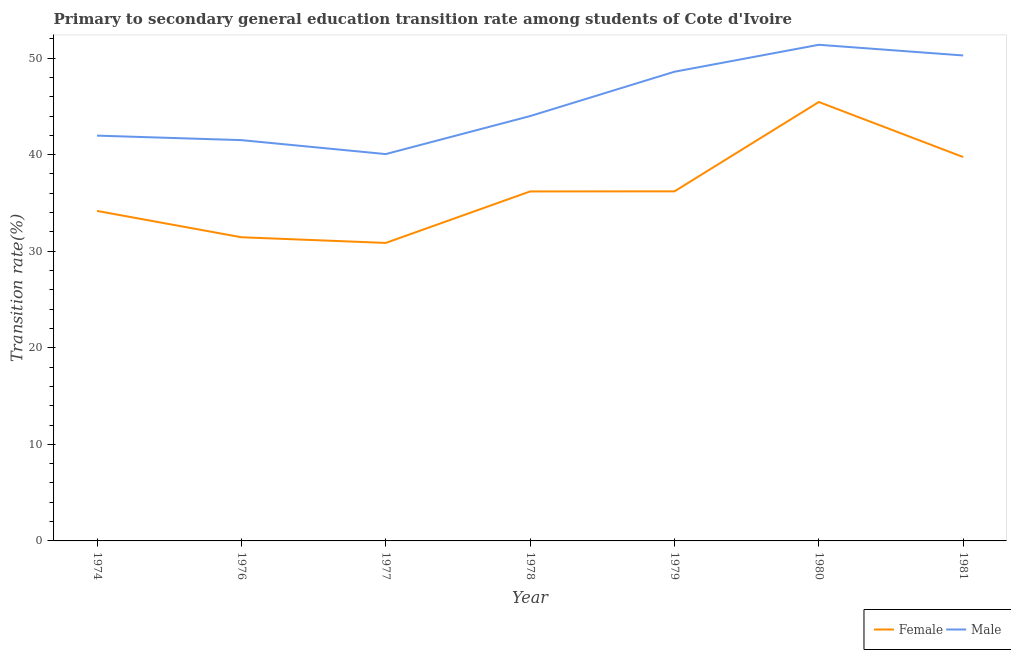How many different coloured lines are there?
Your answer should be very brief. 2. What is the transition rate among female students in 1979?
Ensure brevity in your answer.  36.2. Across all years, what is the maximum transition rate among female students?
Provide a short and direct response. 45.46. Across all years, what is the minimum transition rate among male students?
Offer a terse response. 40.06. In which year was the transition rate among male students maximum?
Your answer should be compact. 1980. What is the total transition rate among female students in the graph?
Offer a terse response. 254.09. What is the difference between the transition rate among male students in 1977 and that in 1978?
Your answer should be compact. -3.94. What is the difference between the transition rate among female students in 1980 and the transition rate among male students in 1978?
Your answer should be very brief. 1.46. What is the average transition rate among female students per year?
Give a very brief answer. 36.3. In the year 1974, what is the difference between the transition rate among female students and transition rate among male students?
Offer a very short reply. -7.8. In how many years, is the transition rate among female students greater than 32 %?
Offer a very short reply. 5. What is the ratio of the transition rate among male students in 1976 to that in 1977?
Make the answer very short. 1.04. Is the transition rate among male students in 1974 less than that in 1981?
Ensure brevity in your answer.  Yes. Is the difference between the transition rate among female students in 1980 and 1981 greater than the difference between the transition rate among male students in 1980 and 1981?
Provide a succinct answer. Yes. What is the difference between the highest and the second highest transition rate among male students?
Keep it short and to the point. 1.11. What is the difference between the highest and the lowest transition rate among male students?
Keep it short and to the point. 11.32. Is the transition rate among male students strictly greater than the transition rate among female students over the years?
Your response must be concise. Yes. Are the values on the major ticks of Y-axis written in scientific E-notation?
Make the answer very short. No. Does the graph contain any zero values?
Make the answer very short. No. Where does the legend appear in the graph?
Ensure brevity in your answer.  Bottom right. What is the title of the graph?
Your answer should be compact. Primary to secondary general education transition rate among students of Cote d'Ivoire. Does "Largest city" appear as one of the legend labels in the graph?
Keep it short and to the point. No. What is the label or title of the Y-axis?
Ensure brevity in your answer.  Transition rate(%). What is the Transition rate(%) in Female in 1974?
Your response must be concise. 34.18. What is the Transition rate(%) of Male in 1974?
Give a very brief answer. 41.97. What is the Transition rate(%) of Female in 1976?
Give a very brief answer. 31.45. What is the Transition rate(%) in Male in 1976?
Your response must be concise. 41.51. What is the Transition rate(%) of Female in 1977?
Keep it short and to the point. 30.86. What is the Transition rate(%) in Male in 1977?
Make the answer very short. 40.06. What is the Transition rate(%) in Female in 1978?
Give a very brief answer. 36.19. What is the Transition rate(%) in Male in 1978?
Your answer should be compact. 44. What is the Transition rate(%) in Female in 1979?
Ensure brevity in your answer.  36.2. What is the Transition rate(%) of Male in 1979?
Your answer should be very brief. 48.59. What is the Transition rate(%) in Female in 1980?
Keep it short and to the point. 45.46. What is the Transition rate(%) in Male in 1980?
Provide a succinct answer. 51.38. What is the Transition rate(%) of Female in 1981?
Offer a very short reply. 39.75. What is the Transition rate(%) in Male in 1981?
Provide a short and direct response. 50.28. Across all years, what is the maximum Transition rate(%) in Female?
Provide a short and direct response. 45.46. Across all years, what is the maximum Transition rate(%) of Male?
Offer a very short reply. 51.38. Across all years, what is the minimum Transition rate(%) of Female?
Provide a short and direct response. 30.86. Across all years, what is the minimum Transition rate(%) in Male?
Offer a terse response. 40.06. What is the total Transition rate(%) of Female in the graph?
Offer a very short reply. 254.09. What is the total Transition rate(%) in Male in the graph?
Offer a terse response. 317.79. What is the difference between the Transition rate(%) of Female in 1974 and that in 1976?
Offer a very short reply. 2.73. What is the difference between the Transition rate(%) of Male in 1974 and that in 1976?
Ensure brevity in your answer.  0.47. What is the difference between the Transition rate(%) of Female in 1974 and that in 1977?
Provide a short and direct response. 3.32. What is the difference between the Transition rate(%) in Male in 1974 and that in 1977?
Your answer should be very brief. 1.91. What is the difference between the Transition rate(%) in Female in 1974 and that in 1978?
Your answer should be very brief. -2.02. What is the difference between the Transition rate(%) of Male in 1974 and that in 1978?
Ensure brevity in your answer.  -2.02. What is the difference between the Transition rate(%) in Female in 1974 and that in 1979?
Your answer should be compact. -2.03. What is the difference between the Transition rate(%) of Male in 1974 and that in 1979?
Your response must be concise. -6.62. What is the difference between the Transition rate(%) of Female in 1974 and that in 1980?
Make the answer very short. -11.28. What is the difference between the Transition rate(%) of Male in 1974 and that in 1980?
Make the answer very short. -9.41. What is the difference between the Transition rate(%) of Female in 1974 and that in 1981?
Your response must be concise. -5.58. What is the difference between the Transition rate(%) in Male in 1974 and that in 1981?
Your answer should be very brief. -8.3. What is the difference between the Transition rate(%) in Female in 1976 and that in 1977?
Your answer should be compact. 0.59. What is the difference between the Transition rate(%) of Male in 1976 and that in 1977?
Offer a terse response. 1.45. What is the difference between the Transition rate(%) of Female in 1976 and that in 1978?
Your answer should be compact. -4.74. What is the difference between the Transition rate(%) in Male in 1976 and that in 1978?
Offer a terse response. -2.49. What is the difference between the Transition rate(%) in Female in 1976 and that in 1979?
Ensure brevity in your answer.  -4.75. What is the difference between the Transition rate(%) of Male in 1976 and that in 1979?
Your answer should be compact. -7.08. What is the difference between the Transition rate(%) in Female in 1976 and that in 1980?
Provide a succinct answer. -14.01. What is the difference between the Transition rate(%) in Male in 1976 and that in 1980?
Ensure brevity in your answer.  -9.87. What is the difference between the Transition rate(%) in Female in 1976 and that in 1981?
Keep it short and to the point. -8.31. What is the difference between the Transition rate(%) of Male in 1976 and that in 1981?
Offer a very short reply. -8.77. What is the difference between the Transition rate(%) of Female in 1977 and that in 1978?
Offer a terse response. -5.33. What is the difference between the Transition rate(%) in Male in 1977 and that in 1978?
Offer a terse response. -3.94. What is the difference between the Transition rate(%) in Female in 1977 and that in 1979?
Your response must be concise. -5.34. What is the difference between the Transition rate(%) in Male in 1977 and that in 1979?
Offer a terse response. -8.53. What is the difference between the Transition rate(%) in Female in 1977 and that in 1980?
Provide a short and direct response. -14.59. What is the difference between the Transition rate(%) of Male in 1977 and that in 1980?
Offer a very short reply. -11.32. What is the difference between the Transition rate(%) in Female in 1977 and that in 1981?
Ensure brevity in your answer.  -8.89. What is the difference between the Transition rate(%) of Male in 1977 and that in 1981?
Provide a short and direct response. -10.21. What is the difference between the Transition rate(%) of Female in 1978 and that in 1979?
Your answer should be very brief. -0.01. What is the difference between the Transition rate(%) in Male in 1978 and that in 1979?
Offer a terse response. -4.59. What is the difference between the Transition rate(%) of Female in 1978 and that in 1980?
Make the answer very short. -9.26. What is the difference between the Transition rate(%) in Male in 1978 and that in 1980?
Provide a short and direct response. -7.38. What is the difference between the Transition rate(%) in Female in 1978 and that in 1981?
Offer a terse response. -3.56. What is the difference between the Transition rate(%) of Male in 1978 and that in 1981?
Your response must be concise. -6.28. What is the difference between the Transition rate(%) in Female in 1979 and that in 1980?
Ensure brevity in your answer.  -9.25. What is the difference between the Transition rate(%) in Male in 1979 and that in 1980?
Provide a succinct answer. -2.79. What is the difference between the Transition rate(%) of Female in 1979 and that in 1981?
Make the answer very short. -3.55. What is the difference between the Transition rate(%) in Male in 1979 and that in 1981?
Give a very brief answer. -1.69. What is the difference between the Transition rate(%) of Female in 1980 and that in 1981?
Make the answer very short. 5.7. What is the difference between the Transition rate(%) of Male in 1980 and that in 1981?
Offer a terse response. 1.11. What is the difference between the Transition rate(%) of Female in 1974 and the Transition rate(%) of Male in 1976?
Your response must be concise. -7.33. What is the difference between the Transition rate(%) in Female in 1974 and the Transition rate(%) in Male in 1977?
Provide a succinct answer. -5.89. What is the difference between the Transition rate(%) in Female in 1974 and the Transition rate(%) in Male in 1978?
Ensure brevity in your answer.  -9.82. What is the difference between the Transition rate(%) of Female in 1974 and the Transition rate(%) of Male in 1979?
Your answer should be compact. -14.41. What is the difference between the Transition rate(%) of Female in 1974 and the Transition rate(%) of Male in 1980?
Offer a terse response. -17.21. What is the difference between the Transition rate(%) in Female in 1974 and the Transition rate(%) in Male in 1981?
Keep it short and to the point. -16.1. What is the difference between the Transition rate(%) of Female in 1976 and the Transition rate(%) of Male in 1977?
Your answer should be very brief. -8.61. What is the difference between the Transition rate(%) in Female in 1976 and the Transition rate(%) in Male in 1978?
Your answer should be compact. -12.55. What is the difference between the Transition rate(%) of Female in 1976 and the Transition rate(%) of Male in 1979?
Keep it short and to the point. -17.14. What is the difference between the Transition rate(%) of Female in 1976 and the Transition rate(%) of Male in 1980?
Provide a short and direct response. -19.93. What is the difference between the Transition rate(%) of Female in 1976 and the Transition rate(%) of Male in 1981?
Keep it short and to the point. -18.83. What is the difference between the Transition rate(%) of Female in 1977 and the Transition rate(%) of Male in 1978?
Provide a succinct answer. -13.14. What is the difference between the Transition rate(%) of Female in 1977 and the Transition rate(%) of Male in 1979?
Ensure brevity in your answer.  -17.73. What is the difference between the Transition rate(%) in Female in 1977 and the Transition rate(%) in Male in 1980?
Offer a very short reply. -20.52. What is the difference between the Transition rate(%) of Female in 1977 and the Transition rate(%) of Male in 1981?
Offer a very short reply. -19.41. What is the difference between the Transition rate(%) of Female in 1978 and the Transition rate(%) of Male in 1979?
Keep it short and to the point. -12.4. What is the difference between the Transition rate(%) of Female in 1978 and the Transition rate(%) of Male in 1980?
Your answer should be compact. -15.19. What is the difference between the Transition rate(%) in Female in 1978 and the Transition rate(%) in Male in 1981?
Provide a succinct answer. -14.08. What is the difference between the Transition rate(%) of Female in 1979 and the Transition rate(%) of Male in 1980?
Make the answer very short. -15.18. What is the difference between the Transition rate(%) of Female in 1979 and the Transition rate(%) of Male in 1981?
Give a very brief answer. -14.07. What is the difference between the Transition rate(%) of Female in 1980 and the Transition rate(%) of Male in 1981?
Your answer should be compact. -4.82. What is the average Transition rate(%) in Female per year?
Your answer should be compact. 36.3. What is the average Transition rate(%) in Male per year?
Your answer should be very brief. 45.4. In the year 1974, what is the difference between the Transition rate(%) in Female and Transition rate(%) in Male?
Your answer should be compact. -7.8. In the year 1976, what is the difference between the Transition rate(%) in Female and Transition rate(%) in Male?
Keep it short and to the point. -10.06. In the year 1977, what is the difference between the Transition rate(%) of Female and Transition rate(%) of Male?
Offer a very short reply. -9.2. In the year 1978, what is the difference between the Transition rate(%) in Female and Transition rate(%) in Male?
Make the answer very short. -7.8. In the year 1979, what is the difference between the Transition rate(%) in Female and Transition rate(%) in Male?
Give a very brief answer. -12.39. In the year 1980, what is the difference between the Transition rate(%) of Female and Transition rate(%) of Male?
Your answer should be compact. -5.93. In the year 1981, what is the difference between the Transition rate(%) in Female and Transition rate(%) in Male?
Offer a very short reply. -10.52. What is the ratio of the Transition rate(%) in Female in 1974 to that in 1976?
Ensure brevity in your answer.  1.09. What is the ratio of the Transition rate(%) of Male in 1974 to that in 1976?
Ensure brevity in your answer.  1.01. What is the ratio of the Transition rate(%) in Female in 1974 to that in 1977?
Give a very brief answer. 1.11. What is the ratio of the Transition rate(%) of Male in 1974 to that in 1977?
Keep it short and to the point. 1.05. What is the ratio of the Transition rate(%) of Female in 1974 to that in 1978?
Offer a very short reply. 0.94. What is the ratio of the Transition rate(%) in Male in 1974 to that in 1978?
Offer a very short reply. 0.95. What is the ratio of the Transition rate(%) of Female in 1974 to that in 1979?
Ensure brevity in your answer.  0.94. What is the ratio of the Transition rate(%) in Male in 1974 to that in 1979?
Your answer should be very brief. 0.86. What is the ratio of the Transition rate(%) of Female in 1974 to that in 1980?
Offer a very short reply. 0.75. What is the ratio of the Transition rate(%) in Male in 1974 to that in 1980?
Give a very brief answer. 0.82. What is the ratio of the Transition rate(%) of Female in 1974 to that in 1981?
Keep it short and to the point. 0.86. What is the ratio of the Transition rate(%) in Male in 1974 to that in 1981?
Your answer should be very brief. 0.83. What is the ratio of the Transition rate(%) of Female in 1976 to that in 1977?
Your answer should be compact. 1.02. What is the ratio of the Transition rate(%) of Male in 1976 to that in 1977?
Your answer should be very brief. 1.04. What is the ratio of the Transition rate(%) of Female in 1976 to that in 1978?
Provide a short and direct response. 0.87. What is the ratio of the Transition rate(%) of Male in 1976 to that in 1978?
Offer a terse response. 0.94. What is the ratio of the Transition rate(%) of Female in 1976 to that in 1979?
Your answer should be very brief. 0.87. What is the ratio of the Transition rate(%) in Male in 1976 to that in 1979?
Offer a terse response. 0.85. What is the ratio of the Transition rate(%) in Female in 1976 to that in 1980?
Your answer should be very brief. 0.69. What is the ratio of the Transition rate(%) of Male in 1976 to that in 1980?
Ensure brevity in your answer.  0.81. What is the ratio of the Transition rate(%) of Female in 1976 to that in 1981?
Offer a terse response. 0.79. What is the ratio of the Transition rate(%) in Male in 1976 to that in 1981?
Ensure brevity in your answer.  0.83. What is the ratio of the Transition rate(%) of Female in 1977 to that in 1978?
Offer a very short reply. 0.85. What is the ratio of the Transition rate(%) of Male in 1977 to that in 1978?
Make the answer very short. 0.91. What is the ratio of the Transition rate(%) in Female in 1977 to that in 1979?
Provide a succinct answer. 0.85. What is the ratio of the Transition rate(%) in Male in 1977 to that in 1979?
Provide a short and direct response. 0.82. What is the ratio of the Transition rate(%) of Female in 1977 to that in 1980?
Give a very brief answer. 0.68. What is the ratio of the Transition rate(%) of Male in 1977 to that in 1980?
Make the answer very short. 0.78. What is the ratio of the Transition rate(%) in Female in 1977 to that in 1981?
Your response must be concise. 0.78. What is the ratio of the Transition rate(%) of Male in 1977 to that in 1981?
Your response must be concise. 0.8. What is the ratio of the Transition rate(%) in Male in 1978 to that in 1979?
Offer a very short reply. 0.91. What is the ratio of the Transition rate(%) in Female in 1978 to that in 1980?
Keep it short and to the point. 0.8. What is the ratio of the Transition rate(%) in Male in 1978 to that in 1980?
Provide a short and direct response. 0.86. What is the ratio of the Transition rate(%) in Female in 1978 to that in 1981?
Your answer should be very brief. 0.91. What is the ratio of the Transition rate(%) of Male in 1978 to that in 1981?
Your answer should be compact. 0.88. What is the ratio of the Transition rate(%) of Female in 1979 to that in 1980?
Your answer should be compact. 0.8. What is the ratio of the Transition rate(%) in Male in 1979 to that in 1980?
Provide a short and direct response. 0.95. What is the ratio of the Transition rate(%) in Female in 1979 to that in 1981?
Offer a terse response. 0.91. What is the ratio of the Transition rate(%) of Male in 1979 to that in 1981?
Keep it short and to the point. 0.97. What is the ratio of the Transition rate(%) in Female in 1980 to that in 1981?
Your response must be concise. 1.14. What is the ratio of the Transition rate(%) in Male in 1980 to that in 1981?
Make the answer very short. 1.02. What is the difference between the highest and the second highest Transition rate(%) of Female?
Provide a succinct answer. 5.7. What is the difference between the highest and the second highest Transition rate(%) of Male?
Ensure brevity in your answer.  1.11. What is the difference between the highest and the lowest Transition rate(%) in Female?
Give a very brief answer. 14.59. What is the difference between the highest and the lowest Transition rate(%) of Male?
Your response must be concise. 11.32. 